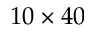<formula> <loc_0><loc_0><loc_500><loc_500>1 0 \times 4 0</formula> 